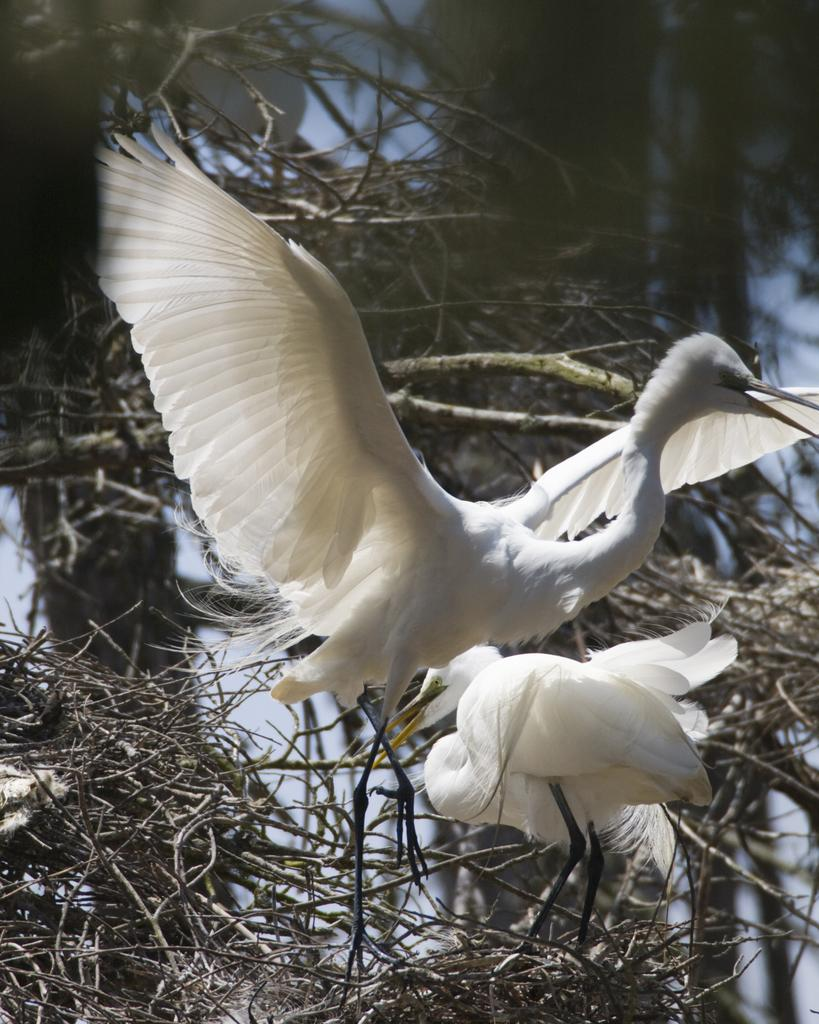How many birds are visible in the image? There are two birds in the image. Where are the birds located in the image? The birds are on branches in the image. What can be observed about the background of the image? The background of the image is blurred. What activity is the baby performing in the image? There is no baby present in the image; it features two birds on branches. 